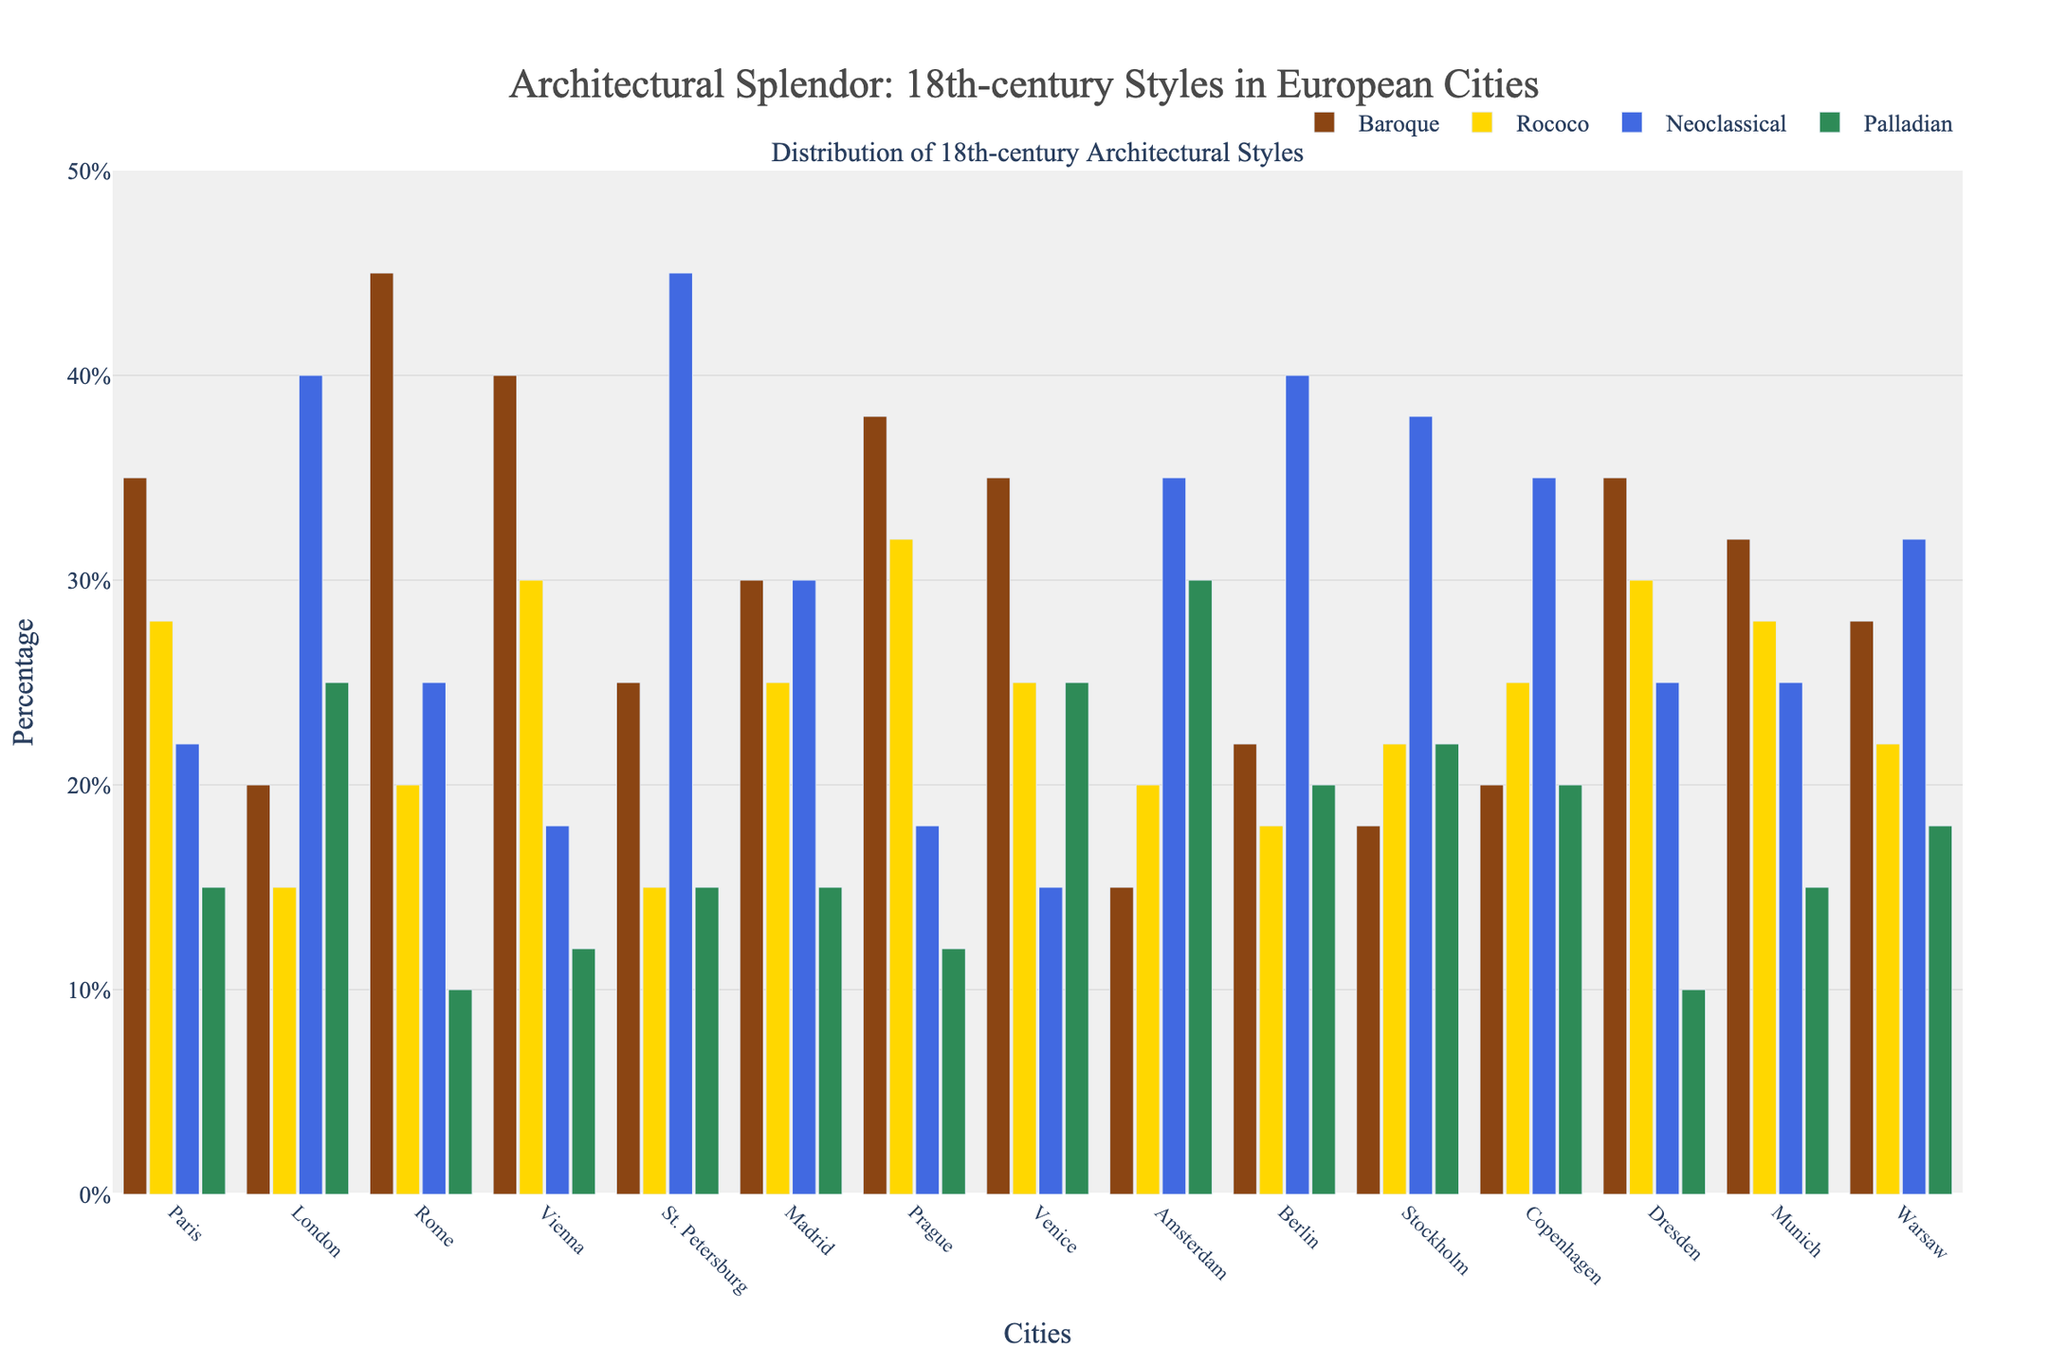Which city has the highest percentage of Baroque architecture? To find the city with the highest Baroque percentage, look at the heights of the Baroque bars across all cities. The tallest Baroque bar is for Rome, at 45%.
Answer: Rome Which city has the lowest percentage of Neoclassical architecture? To determine this, check the heights of the Neoclassical bars. The city with the shortest Neoclassical bar is Venice, at 15%.
Answer: Venice What's the total percentage of Rococo architecture in Paris and Vienna? Sum up the percentages of Rococo architecture in both cities: Paris (28%) + Vienna (30%) = 58%.
Answer: 58% Which two cities have the same percentage of Palladian architecture, and what is that percentage? Observe the Palladian bars for cities with matching heights. Both Paris and St. Petersburg have Palladian architecture at 15%.
Answer: Paris and St. Petersburg, 15% How much higher is the percentage of Baroque architecture in Rome compared to Berlin? Find the difference in the Baroque percentages between Rome (45%) and Berlin (22%): 45% - 22% = 23%.
Answer: 23% Which cities have more than 25% Rococo architecture, and what are their percentages? Look for cities with Rococo bars taller than 25%. These cities and their percentages are: Paris (28%), Vienna (30%), Prague (32%), Madrid (25%, just on the threshold), and Dresden (30%).
Answer: Paris (28%), Vienna (30%), Prague (32%), Madrid (25%), Dresden (30%) What is the average percentage of Neoclassical architecture across all cities? To get the average, sum up all Neoclassical percentages and divide by the number of cities. Total Neoclassical percentages: 22 + 40 + 25 + 18 + 45 + 30 + 18 + 15 + 35 + 40 + 38 + 35 + 25 + 25 + 32 = 443. There are 15 cities, so the average is 443/15 ≈ 29.53%.
Answer: ~29.53% How does the percentage of Palladian architecture in Amsterdam compare to that in London? Check the Palladian bars for Amsterdam (30%) and London (25%). Amsterdam's Palladian percentage is 5% higher than London's.
Answer: Amsterdam is 5% higher Which city shows a higher percentage of Neoclassical architecture than Baroque, and what are these percentages? Compare the Neoclassical and Baroque bars within each city. In London, Neoclassical (40%) is higher than Baroque (20%), and the same is true for St. Petersburg with Neoclassical (45%) over Baroque (25%).
Answer: London: Neoclassical (40%), Baroque (20%); St. Petersburg: Neoclassical (45%), Baroque (25%) 